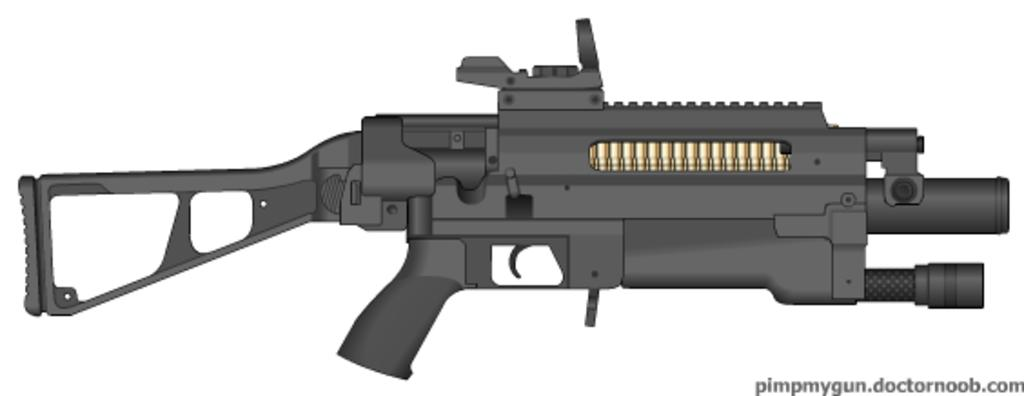What type of image is being described? The image is a drawing. What object is depicted in the drawing? There is a gun depicted in the drawing. Where is the kitten playing with a doll in the office in the image? There is no kitten, doll, or office present in the image; it only depicts a gun. 